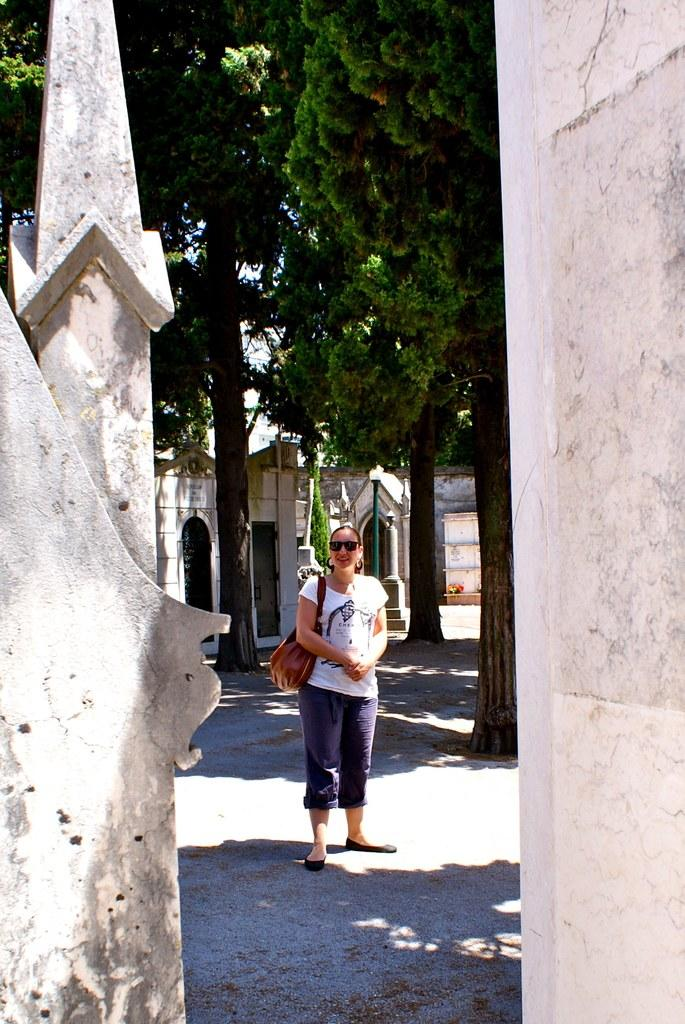Who is present in the image? There is a woman in the image. What is the woman doing in the image? The woman is standing in the image. What is the woman holding or carrying in the image? The woman is carrying a bag in the image. What can be seen in the background of the image? There are buildings and trees visible in the background of the image. How many horses are visible in the image? There are no horses present in the image. What type of mitten is the woman wearing in the image? The woman is not wearing a mitten in the image. 